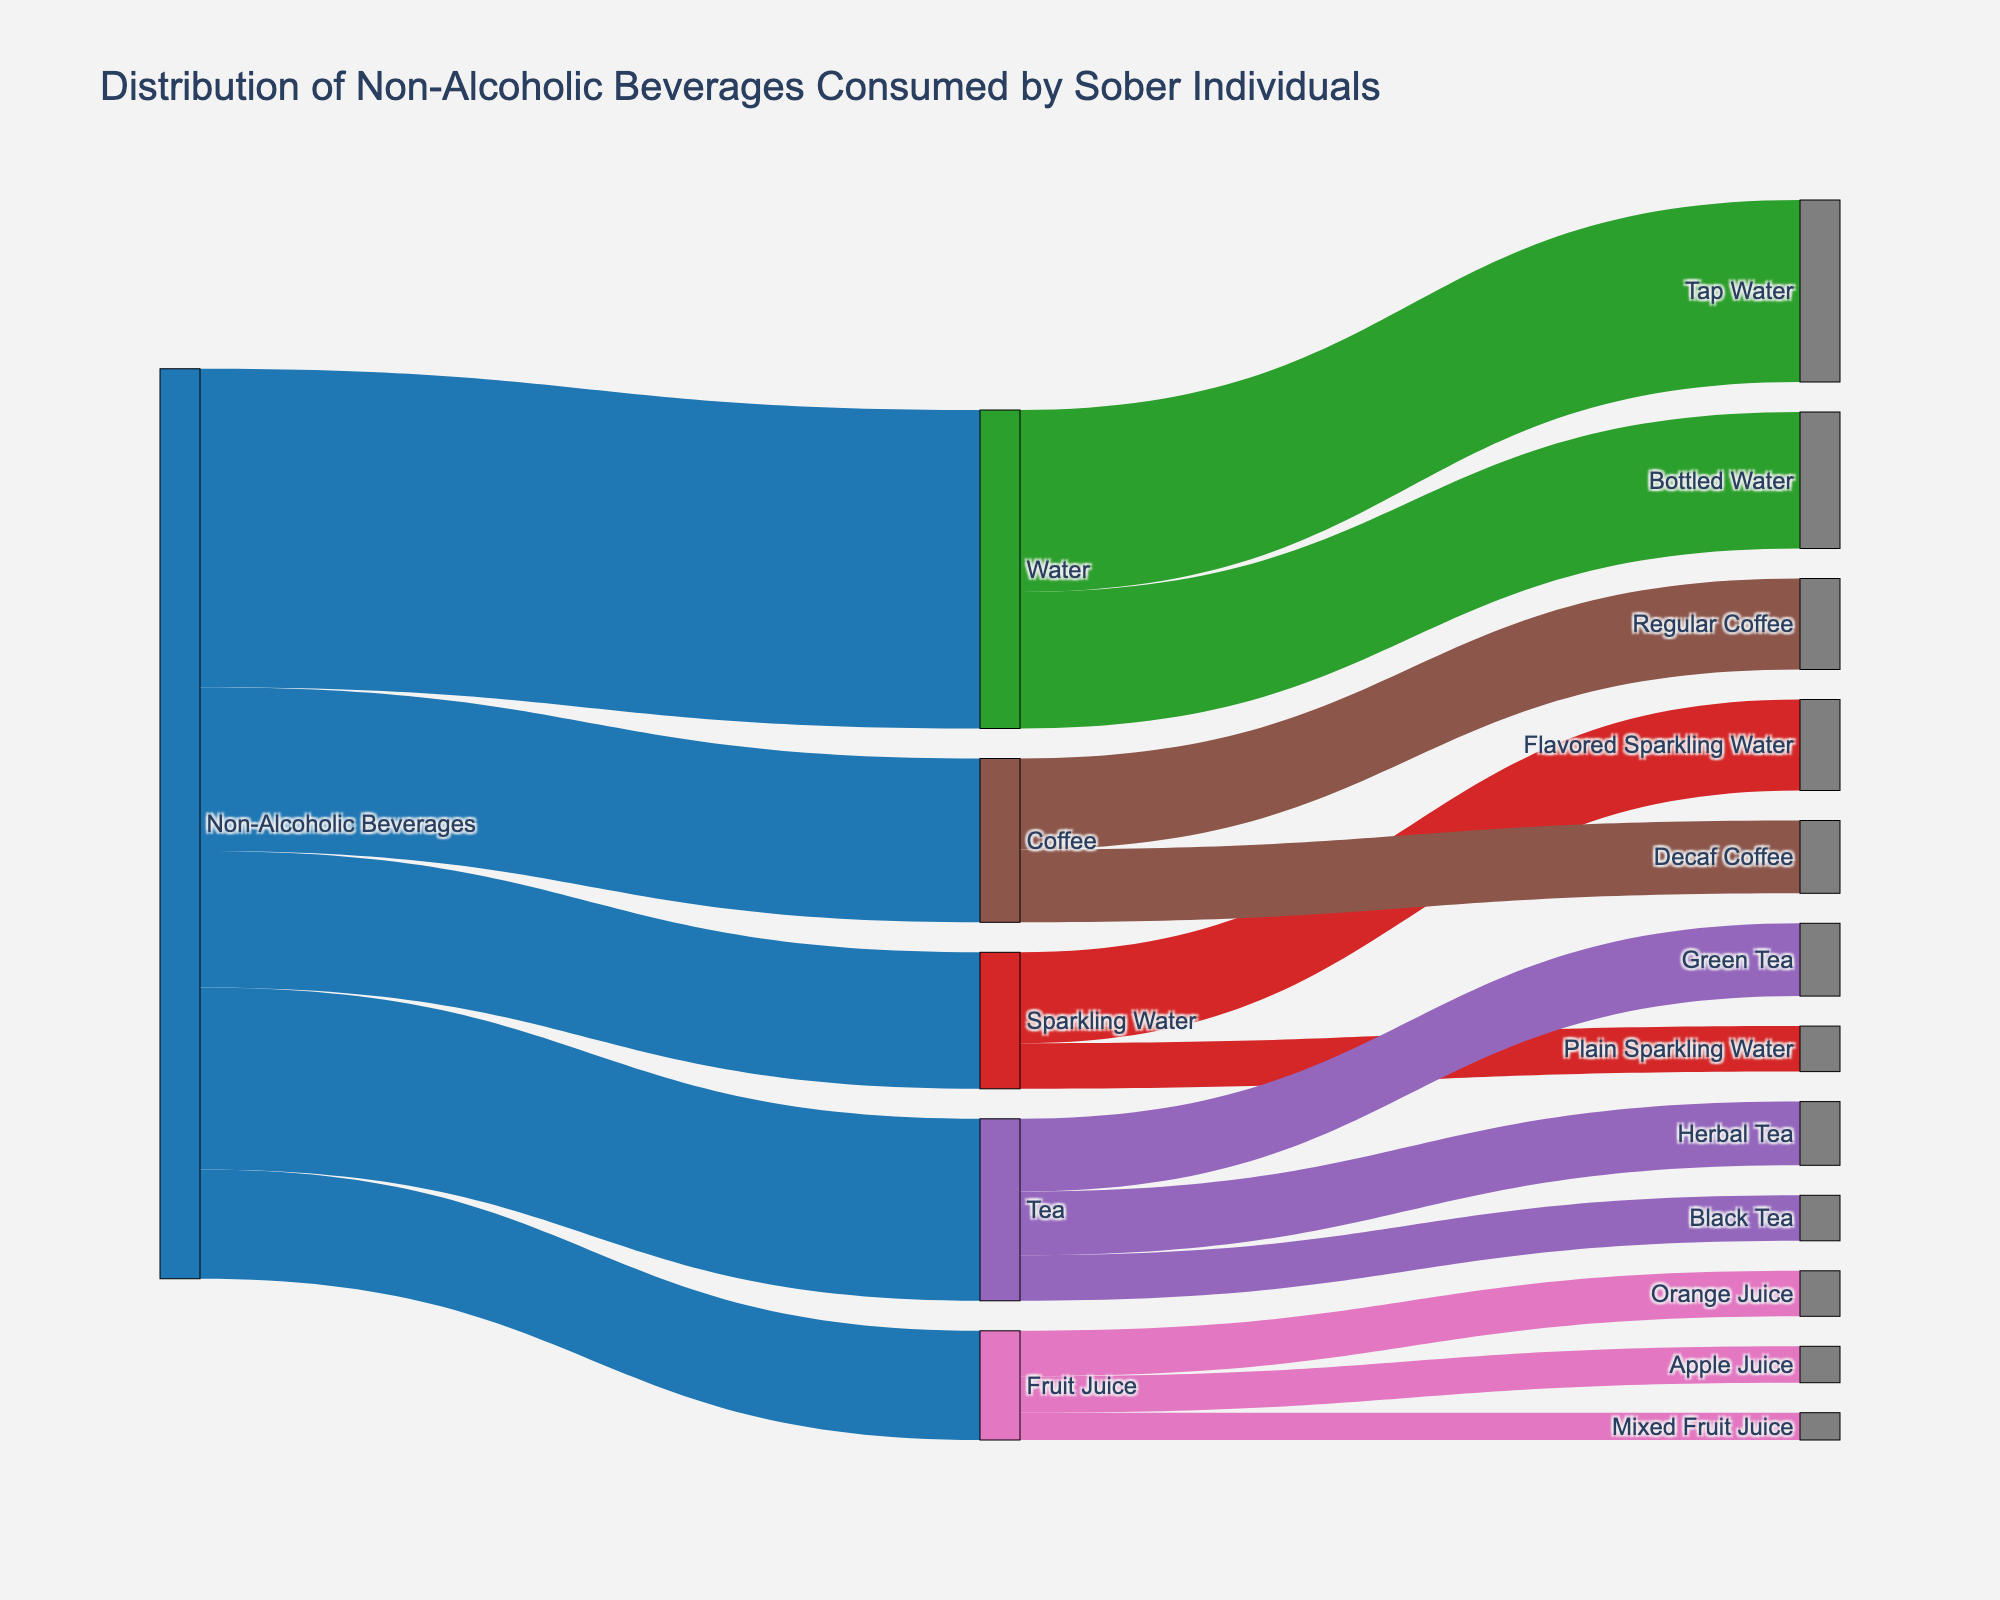What is the title of the Sankey diagram? The title is displayed at the top of the figure. It usually gives a summary of what the diagram represents.
Answer: Distribution of Non-Alcoholic Beverages Consumed by Sober Individuals How many types of non-alcoholic beverages are shown in the diagram? Count the main categories that stem from "Non-Alcoholic Beverages".
Answer: 5 Which beverage category has the highest consumption value directly under "Non-Alcoholic Beverages"? Look at the values for each category branching out from "Non-Alcoholic Beverages" and note the highest one.
Answer: Water How many subcategories are there under the "Tea" category? Count the branches coming out of the "Tea" category.
Answer: 3 Which subcategory under "Sparkling Water" has a higher consumption value? Compare the values of subcategories branching out from "Sparkling Water".
Answer: Flavored Sparkling Water What is the combined value of consumption for all types of coffee? Add the values for "Regular Coffee" and "Decaf Coffee".
Answer: 18 Compare the total consumption value of Water vs. Tea. Which is greater and by how much? Sum up the consumption values for each subcategory under "Water" and "Tea". Then, find the difference between the two sums. 
Water: 20 (Tap Water) + 15 (Bottled Water) = 35
Tea: 8 (Green Tea) + 7 (Herbal Tea) + 5 (Black Tea) = 20
Difference: 35 - 20 = 15
Answer: Water by 15 What is the average consumption value for the subcategories under "Fruit Juice"? Add the consumption values for each subcategory under the "Fruit Juice" category and divide by the number of subcategories.
(5 + 4 + 3) / 3
Answer: 4 Which category has more diverse subcategories: Coffee or Fruit Juice? Compare the number of branches under "Coffee" and "Fruit Juice". Coffee has 2 branches (Regular Coffee, Decaf Coffee), and Fruit Juice has 3 branches (Orange Juice, Apple Juice, Mixed Fruit Juice).
Answer: Fruit Juice Which type of tea has the lowest consumption value? Look at the values for each tea type and identify the smallest one.
Answer: Black Tea 